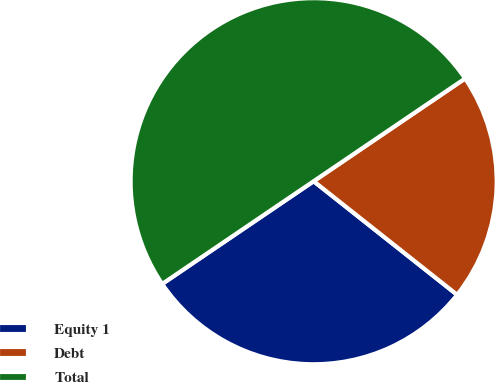<chart> <loc_0><loc_0><loc_500><loc_500><pie_chart><fcel>Equity 1<fcel>Debt<fcel>Total<nl><fcel>29.86%<fcel>20.14%<fcel>50.0%<nl></chart> 